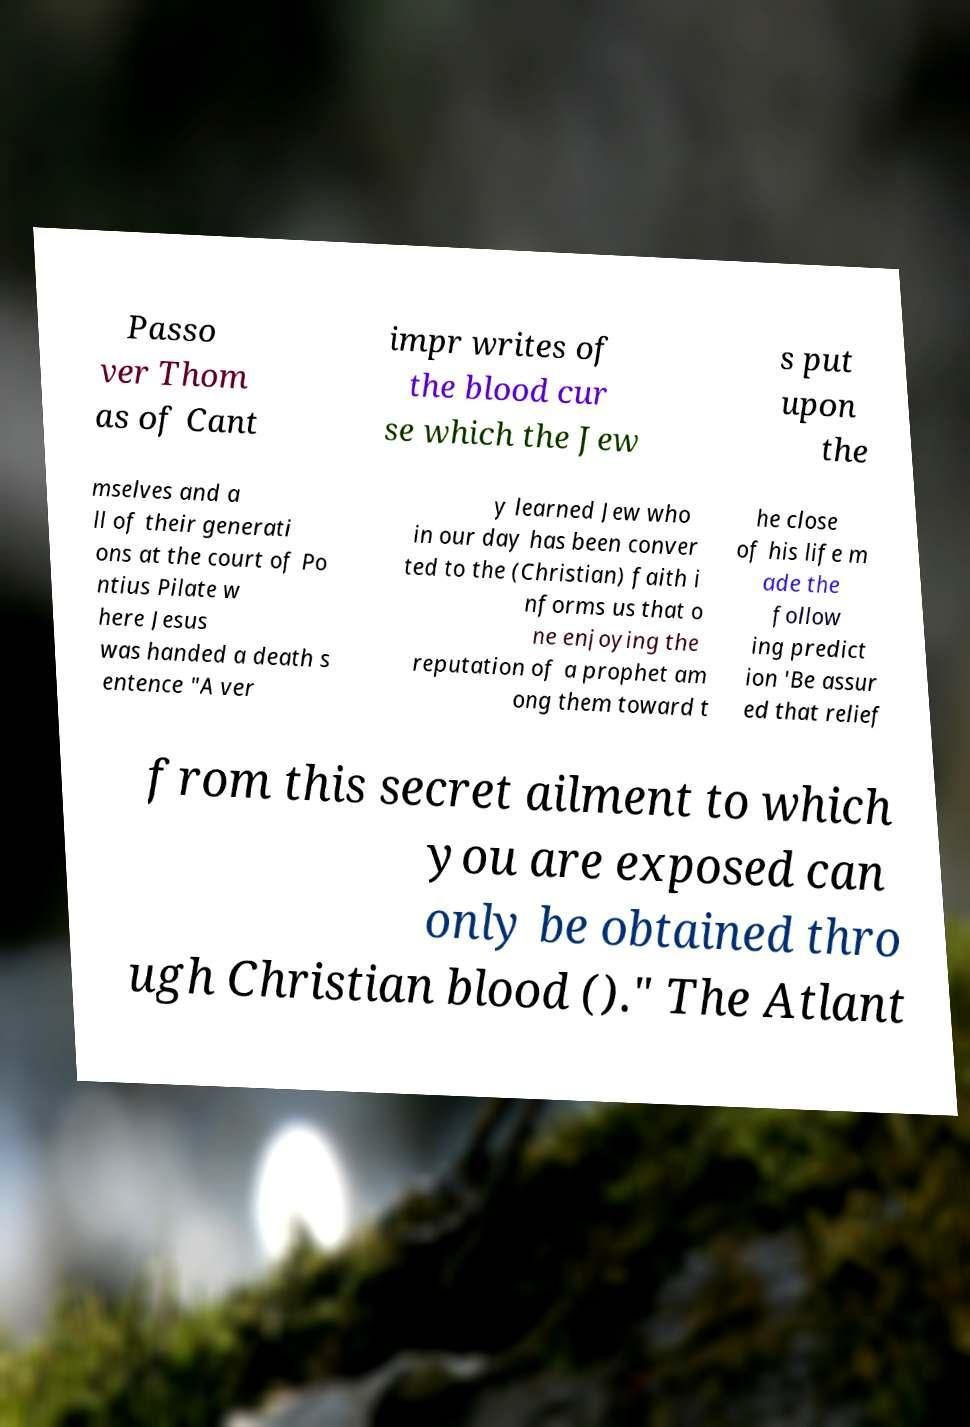For documentation purposes, I need the text within this image transcribed. Could you provide that? Passo ver Thom as of Cant impr writes of the blood cur se which the Jew s put upon the mselves and a ll of their generati ons at the court of Po ntius Pilate w here Jesus was handed a death s entence "A ver y learned Jew who in our day has been conver ted to the (Christian) faith i nforms us that o ne enjoying the reputation of a prophet am ong them toward t he close of his life m ade the follow ing predict ion 'Be assur ed that relief from this secret ailment to which you are exposed can only be obtained thro ugh Christian blood ()." The Atlant 